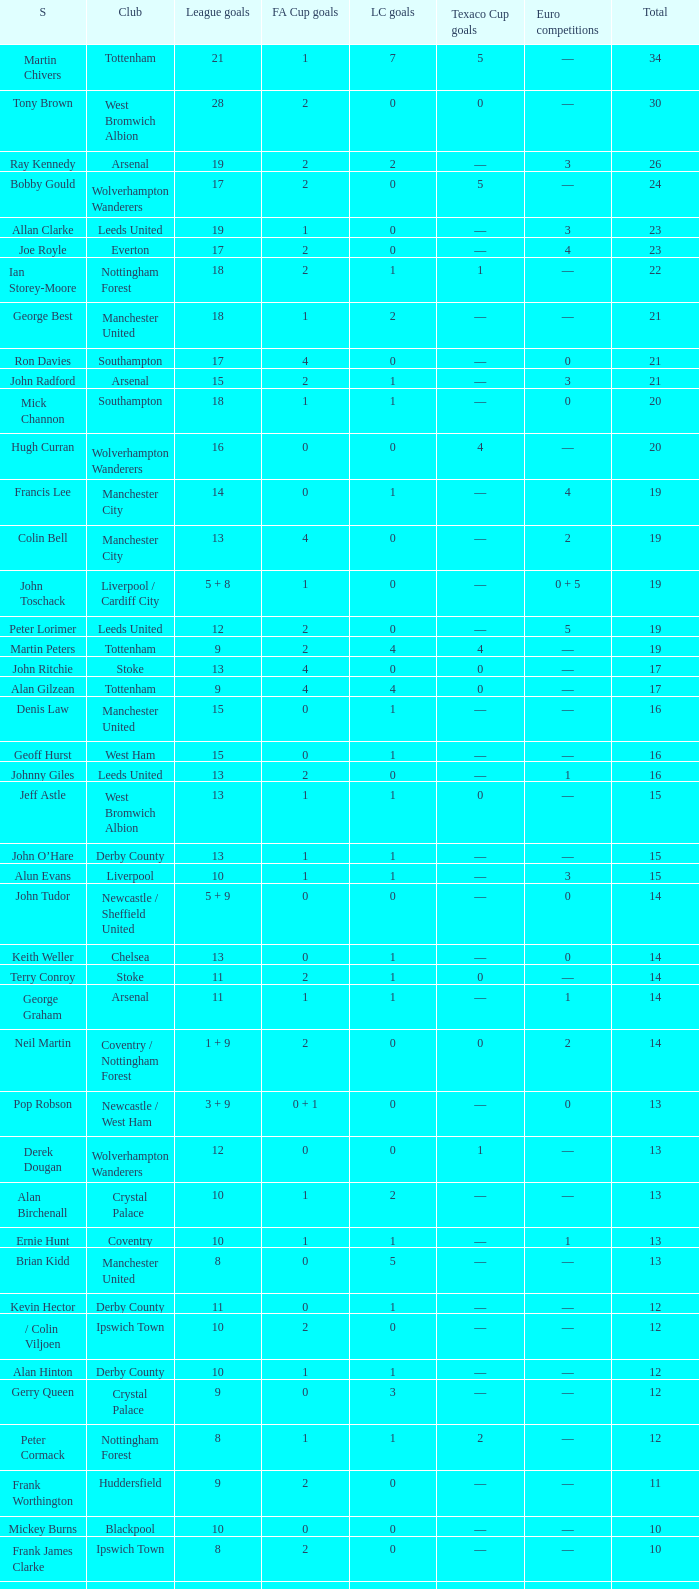What is the total number of Total, when Club is Leeds United, and when League Goals is 13? 1.0. 